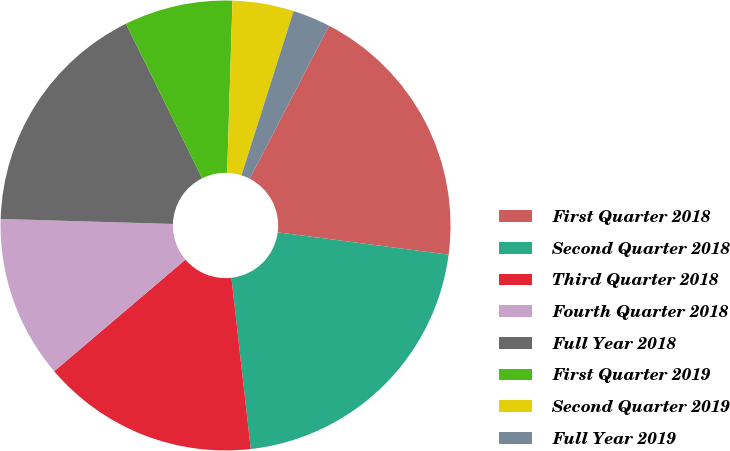Convert chart. <chart><loc_0><loc_0><loc_500><loc_500><pie_chart><fcel>First Quarter 2018<fcel>Second Quarter 2018<fcel>Third Quarter 2018<fcel>Fourth Quarter 2018<fcel>Full Year 2018<fcel>First Quarter 2019<fcel>Second Quarter 2019<fcel>Full Year 2019<nl><fcel>19.46%<fcel>21.14%<fcel>15.57%<fcel>11.68%<fcel>17.24%<fcel>7.79%<fcel>4.4%<fcel>2.72%<nl></chart> 